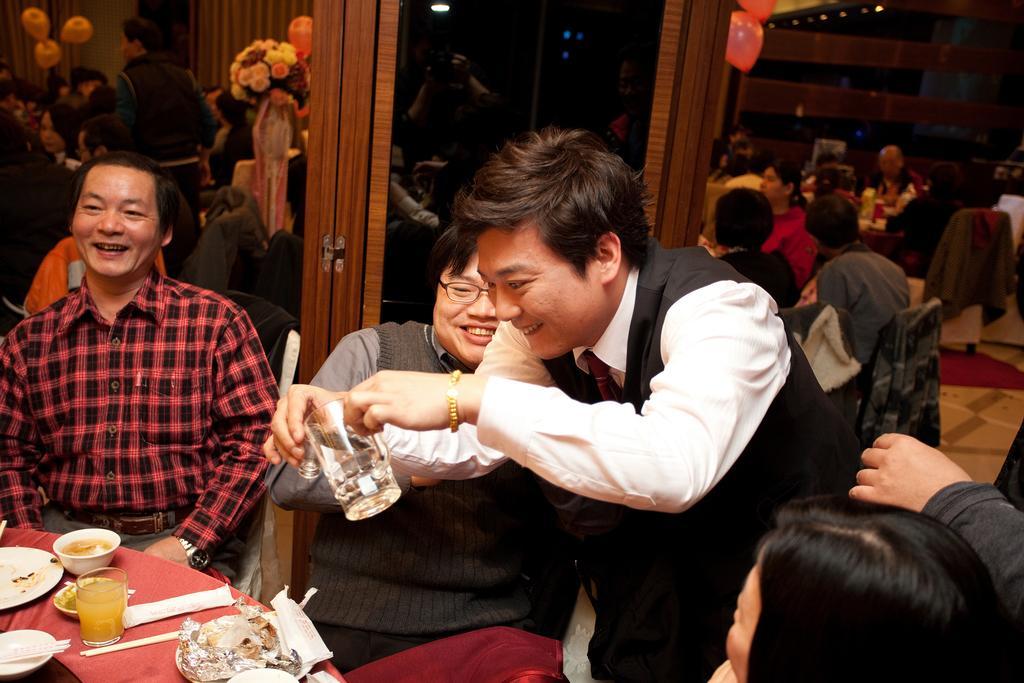In one or two sentences, can you explain what this image depicts? In this picture we can see glasses, plates, bowl, aluminium foil, chopsticks, food items, mirrors, flowers and some people are smiling and some people are sitting on chairs and some objects. 